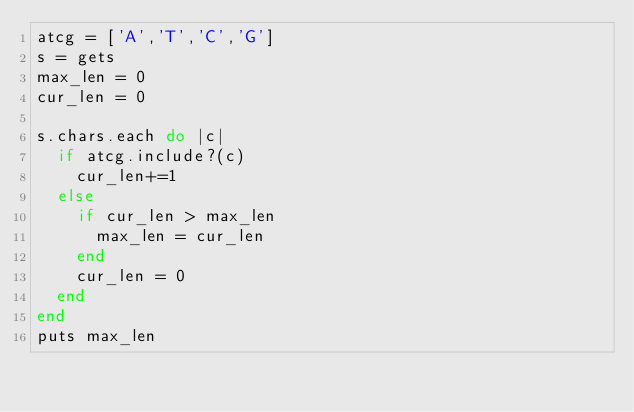Convert code to text. <code><loc_0><loc_0><loc_500><loc_500><_Ruby_>atcg = ['A','T','C','G']
s = gets
max_len = 0
cur_len = 0

s.chars.each do |c|
  if atcg.include?(c)
    cur_len+=1
  else
    if cur_len > max_len
      max_len = cur_len
    end
    cur_len = 0
  end
end
puts max_len</code> 